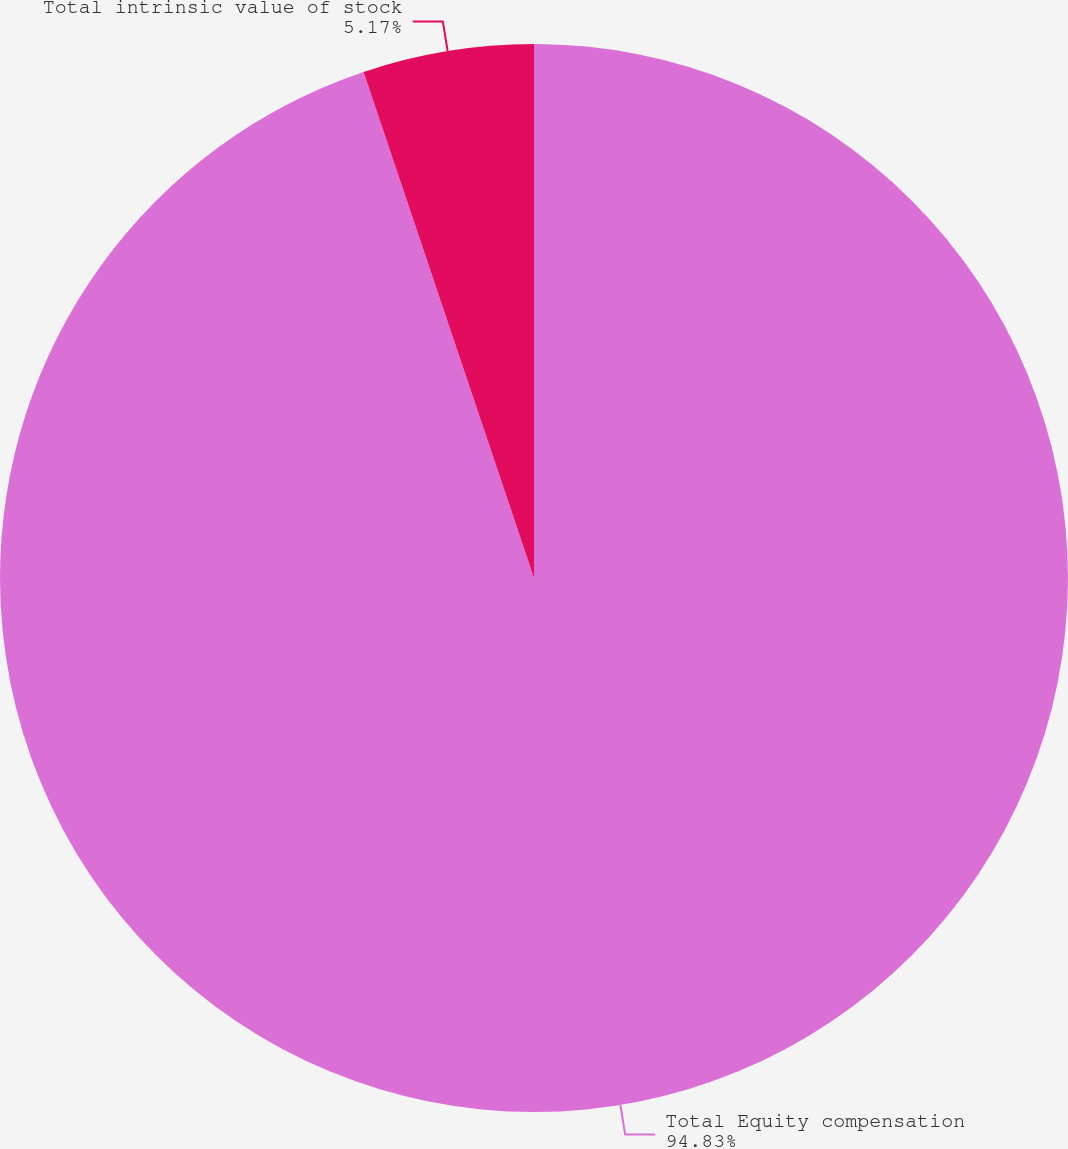Convert chart to OTSL. <chart><loc_0><loc_0><loc_500><loc_500><pie_chart><fcel>Total Equity compensation<fcel>Total intrinsic value of stock<nl><fcel>94.83%<fcel>5.17%<nl></chart> 